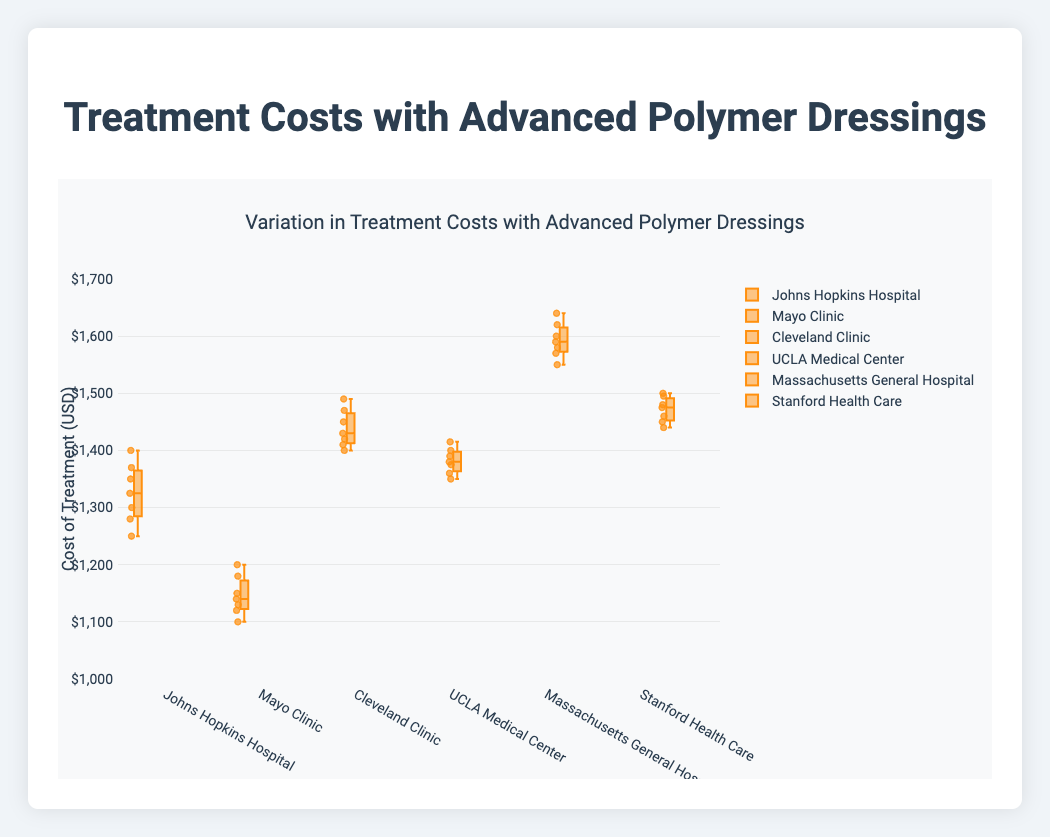What is the title of the plot? The title of the plot is clearly stated at the top of the figure.
Answer: "Variation in Treatment Costs with Advanced Polymer Dressings" Which hospital has the highest median cost of treatment? The median value is represented by the line inside the box. Massachusetts General Hospital has the highest line among all hospitals.
Answer: Massachusetts General Hospital What is the cost range for treatments at Johns Hopkins Hospital? The cost range is represented by the whiskers of the box plot. For Johns Hopkins Hospital, the minimum and maximum values are 1250 and 1400 respectively.
Answer: 1250 - 1400 How do the upper quartiles of Mayo Clinic and Cleveland Clinic compare? The upper quartile (75th percentile) is the top edge of the box. Comparing the top edges of Mayo Clinic and Cleveland Clinic, Cleveland Clinic has a higher upper quartile.
Answer: Cleveland Clinic is higher than Mayo Clinic Which hospital has the widest cost distribution? The width of the distribution is indicated by the range from the minimum to the maximum value (length of whiskers). Massachusetts General Hospital has the widest distribution from 1550 to 1640.
Answer: Massachusetts General Hospital What is the difference between the median treatment costs of Stanford Health Care and UCLA Medical Center? The median values indicated by the lines inside the boxes are at 1475 for Stanford Health Care and 1375 for UCLA Medical Center. Subtract 1375 from 1475 to get the difference.
Answer: 100 USD Are there any hospitals with overlapping cost ranges? Overlapping cost ranges can be seen by comparing the whiskers of the boxes. For example, the cost ranges from Johns Hopkins Hospital (1250 - 1400) and UCLA Medical Center (1350 - 1415) overlap.
Answer: Yes How does the median treatment cost of Mayo Clinic compare to Johns Hopkins Hospital? Compare the median lines. Mayo Clinic's median is at 1150, while Johns Hopkins Hospital's median is at 1350, making Johns Hopkins more expensive.
Answer: Johns Hopkins Hospital is more expensive Which hospital's treatment cost is the most consistent (least variability)? Consistency is indicated by the narrowest box plot. Mayo Clinic has the shortest box and whiskers range, suggesting the least variation.
Answer: Mayo Clinic 